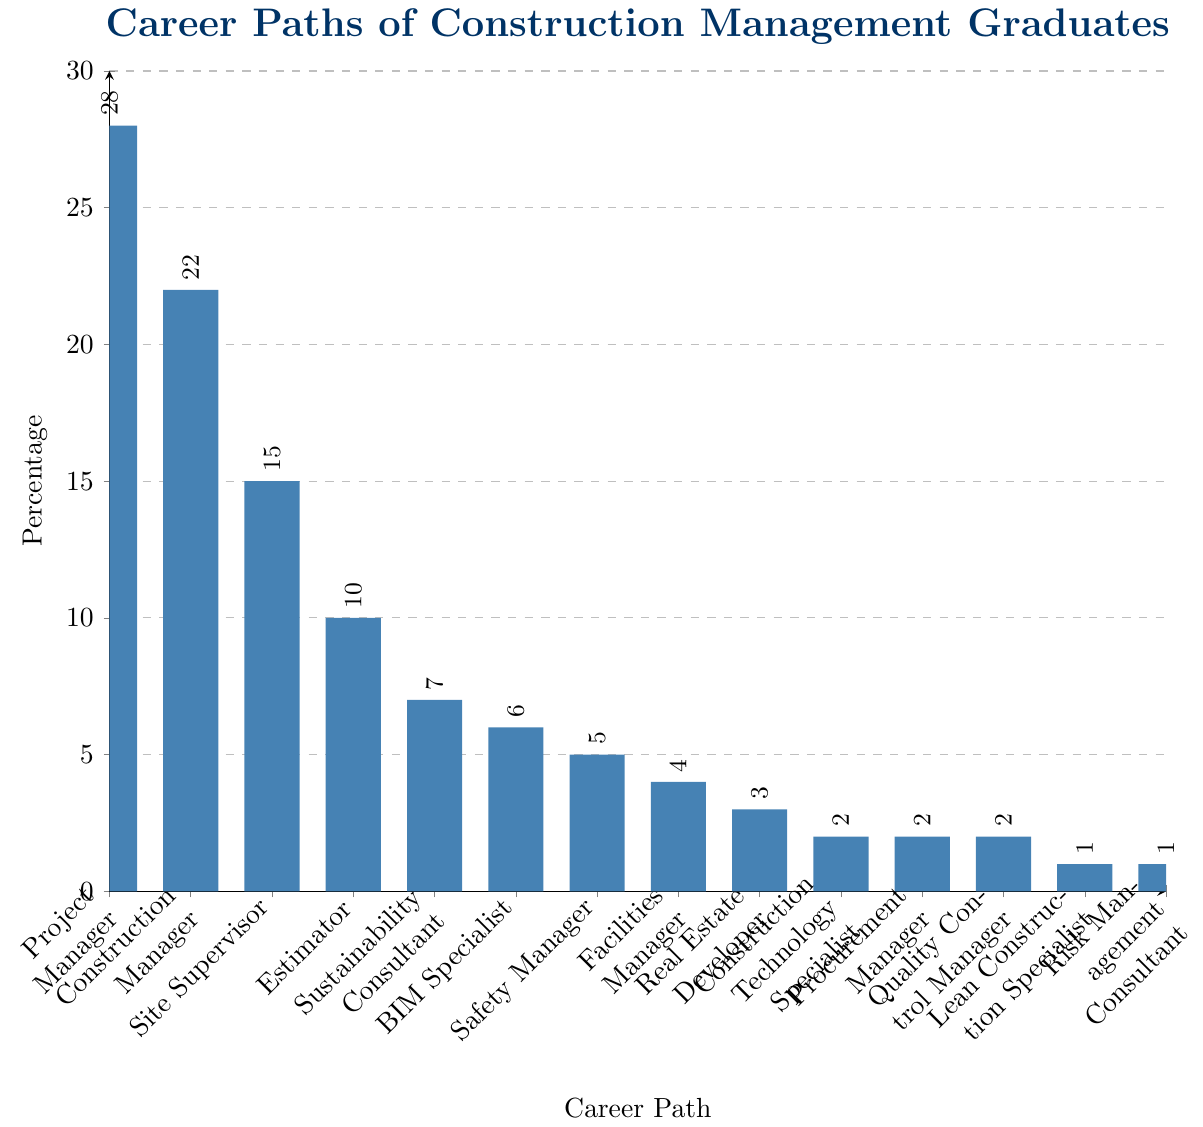Which career path do the highest percentage of construction management graduates choose? The chart shows the percentage of graduates for each career path. The tallest bar represents Project Manager with 28%.
Answer: Project Manager Which two career paths have the same percentage of graduates? The chart displays multiple career paths divided by percentages. Three pairs share the same percentage of 2%, which are Construction Technology Specialist, Procurement Manager, and Quality Control Manager.
Answer: Construction Technology Specialist, Procurement Manager, Quality Control Manager How much higher is the percentage of graduates who become Project Managers compared to those who become Site Supervisors? The percentage of Project Managers is 28%, and the percentage of Site Supervisors is 15%. The difference can be calculated as 28 - 15.
Answer: 13 What is the combined percentage of graduates working as Safety Managers, Facilities Managers, and Real Estate Developers? The percentages for Safety Managers, Facilities Managers, and Real Estate Developers are 5%, 4%, and 3% respectively. Adding them together gives 5 + 4 + 3.
Answer: 12 What is the average percentage of graduates in the roles listed below 5%? The percentages for roles below 5% are Real Estate Developer (3%), Construction Technology Specialist (2%), Procurement Manager (2%), Quality Control Manager (2%), Lean Construction Specialist (1%), and Risk Management Consultant (1%). Summing these values gives 3 + 2 + 2 + 2 + 1 + 1 = 11. Dividing by the number of roles, which is 6, the average is 11 / 6.
Answer: 1.83 Which role has exactly a percentage of 10%? The chart displays the percentage of graduates for each role. The role with a 10% representation is Estimator.
Answer: Estimator How many roles have a higher percentage than Safety Managers? The percentage for Safety Managers is 5%. Roles with percentages higher than this are Project Manager (28%), Construction Manager (22%), Site Supervisor (15%), Estimator (10%), Sustainability Consultant (7%), and BIM Specialist (6%) – totaling six roles.
Answer: 6 What is the difference in percentage between Construction Managers and BIM Specialists? The percentage for Construction Managers is 22%, and for BIM Specialists, it is 6%. The difference can be calculated as 22 - 6.
Answer: 16 Which has more graduates, Facilities Managers or Estimators? The chart shows that Facilities Managers have 4% and Estimators have 10%. Estimators have a higher percentage than Facilities Managers.
Answer: Estimators 